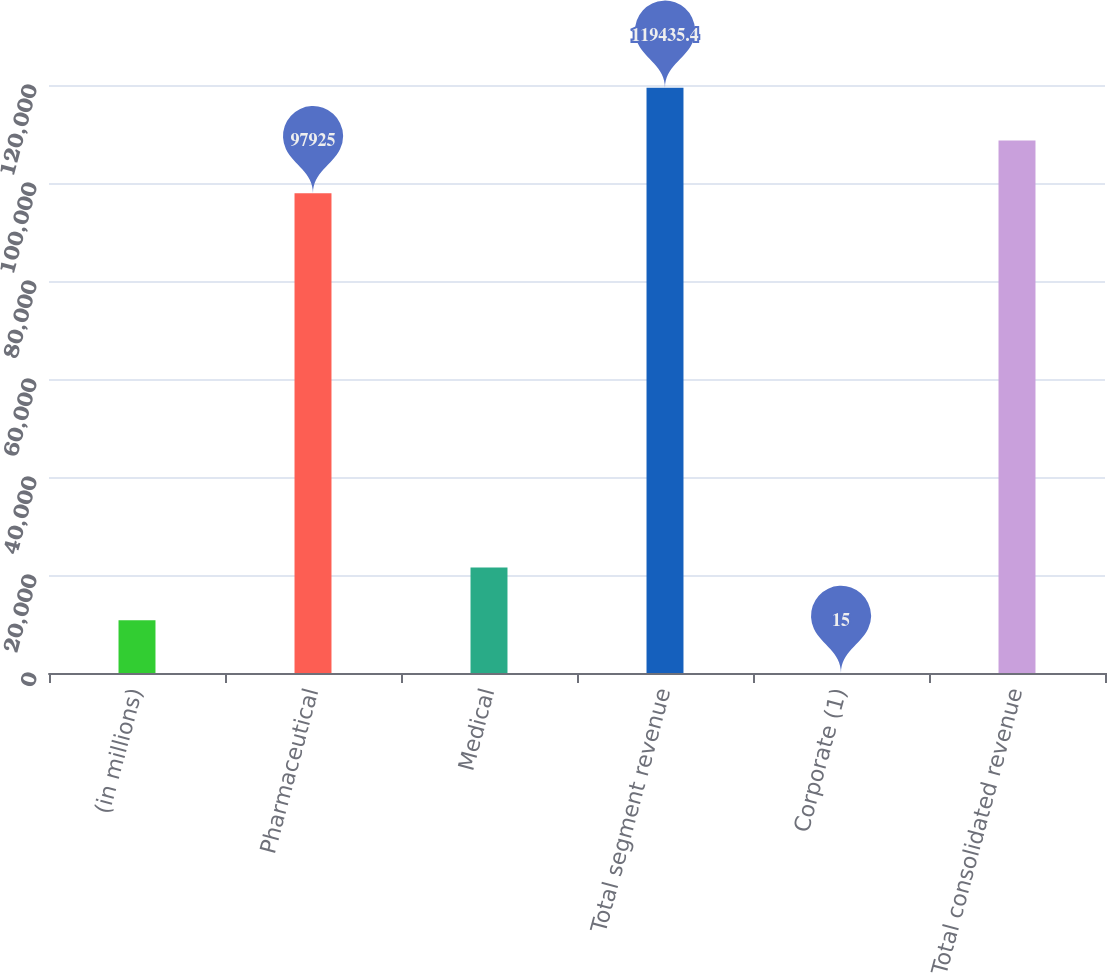<chart> <loc_0><loc_0><loc_500><loc_500><bar_chart><fcel>(in millions)<fcel>Pharmaceutical<fcel>Medical<fcel>Total segment revenue<fcel>Corporate (1)<fcel>Total consolidated revenue<nl><fcel>10770.2<fcel>97925<fcel>21525.4<fcel>119435<fcel>15<fcel>108680<nl></chart> 